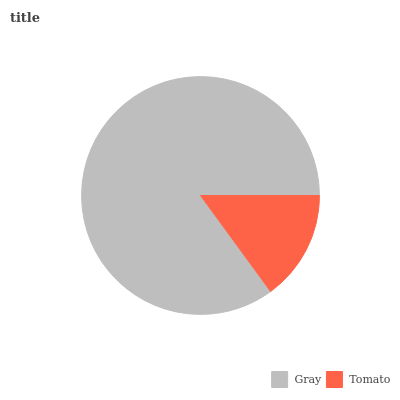Is Tomato the minimum?
Answer yes or no. Yes. Is Gray the maximum?
Answer yes or no. Yes. Is Tomato the maximum?
Answer yes or no. No. Is Gray greater than Tomato?
Answer yes or no. Yes. Is Tomato less than Gray?
Answer yes or no. Yes. Is Tomato greater than Gray?
Answer yes or no. No. Is Gray less than Tomato?
Answer yes or no. No. Is Gray the high median?
Answer yes or no. Yes. Is Tomato the low median?
Answer yes or no. Yes. Is Tomato the high median?
Answer yes or no. No. Is Gray the low median?
Answer yes or no. No. 